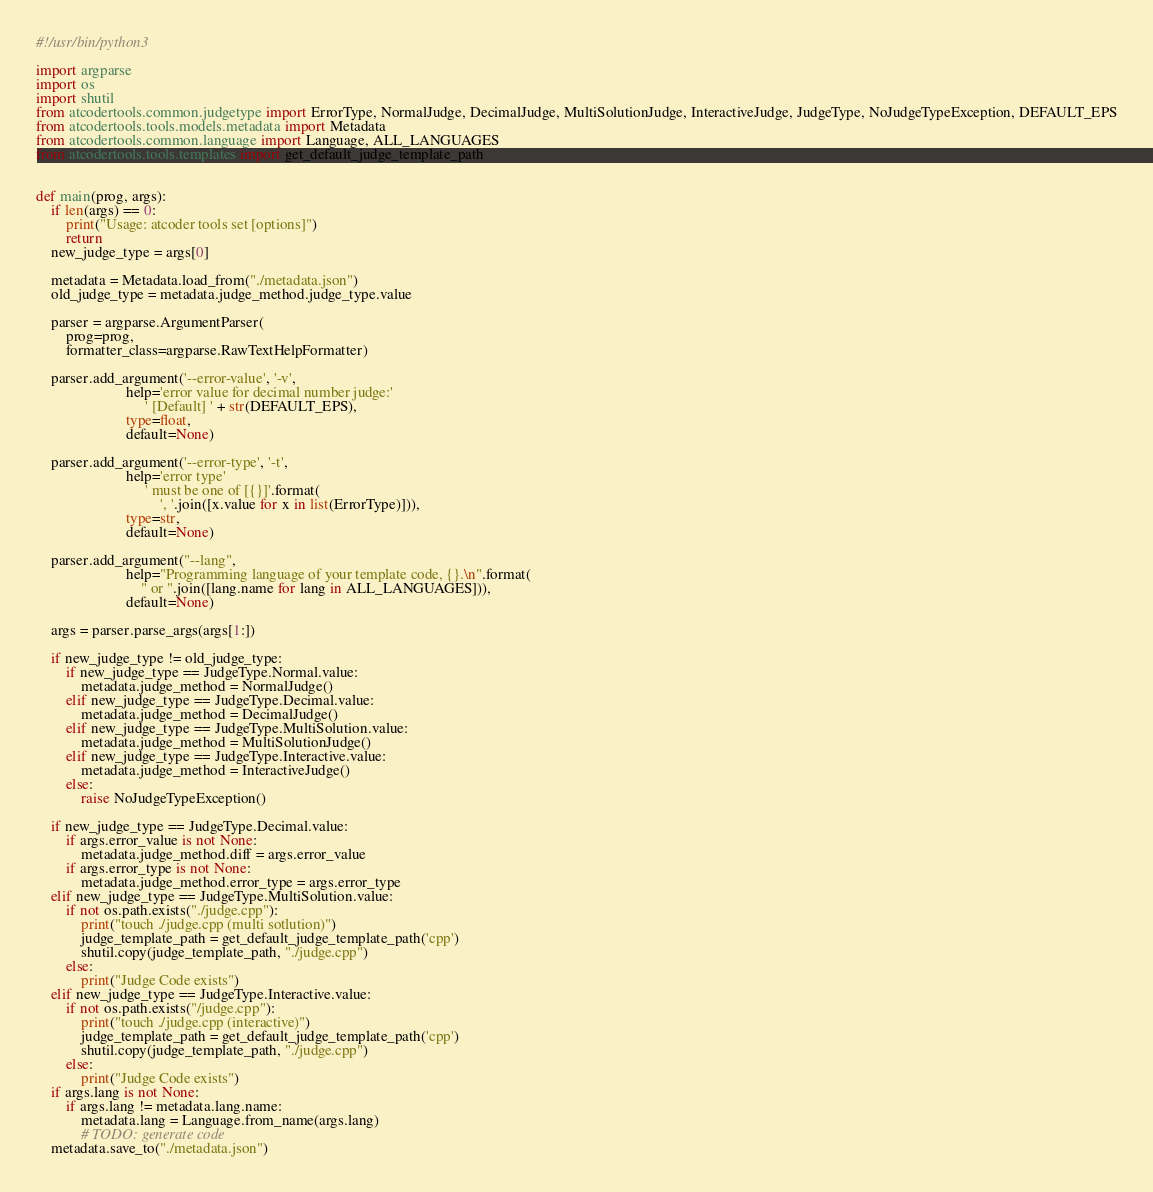Convert code to text. <code><loc_0><loc_0><loc_500><loc_500><_Python_>#!/usr/bin/python3

import argparse
import os
import shutil
from atcodertools.common.judgetype import ErrorType, NormalJudge, DecimalJudge, MultiSolutionJudge, InteractiveJudge, JudgeType, NoJudgeTypeException, DEFAULT_EPS
from atcodertools.tools.models.metadata import Metadata
from atcodertools.common.language import Language, ALL_LANGUAGES
from atcodertools.tools.templates import get_default_judge_template_path


def main(prog, args):
    if len(args) == 0:
        print("Usage: atcoder tools set [options]")
        return
    new_judge_type = args[0]

    metadata = Metadata.load_from("./metadata.json")
    old_judge_type = metadata.judge_method.judge_type.value

    parser = argparse.ArgumentParser(
        prog=prog,
        formatter_class=argparse.RawTextHelpFormatter)

    parser.add_argument('--error-value', '-v',
                        help='error value for decimal number judge:'
                             ' [Default] ' + str(DEFAULT_EPS),
                        type=float,
                        default=None)

    parser.add_argument('--error-type', '-t',
                        help='error type'
                             ' must be one of [{}]'.format(
                                 ', '.join([x.value for x in list(ErrorType)])),
                        type=str,
                        default=None)

    parser.add_argument("--lang",
                        help="Programming language of your template code, {}.\n".format(
                            " or ".join([lang.name for lang in ALL_LANGUAGES])),
                        default=None)

    args = parser.parse_args(args[1:])

    if new_judge_type != old_judge_type:
        if new_judge_type == JudgeType.Normal.value:
            metadata.judge_method = NormalJudge()
        elif new_judge_type == JudgeType.Decimal.value:
            metadata.judge_method = DecimalJudge()
        elif new_judge_type == JudgeType.MultiSolution.value:
            metadata.judge_method = MultiSolutionJudge()
        elif new_judge_type == JudgeType.Interactive.value:
            metadata.judge_method = InteractiveJudge()
        else:
            raise NoJudgeTypeException()

    if new_judge_type == JudgeType.Decimal.value:
        if args.error_value is not None:
            metadata.judge_method.diff = args.error_value
        if args.error_type is not None:
            metadata.judge_method.error_type = args.error_type
    elif new_judge_type == JudgeType.MultiSolution.value:
        if not os.path.exists("./judge.cpp"):
            print("touch ./judge.cpp (multi sotlution)")
            judge_template_path = get_default_judge_template_path('cpp')
            shutil.copy(judge_template_path, "./judge.cpp")
        else:
            print("Judge Code exists")
    elif new_judge_type == JudgeType.Interactive.value:
        if not os.path.exists("/judge.cpp"):
            print("touch ./judge.cpp (interactive)")
            judge_template_path = get_default_judge_template_path('cpp')
            shutil.copy(judge_template_path, "./judge.cpp")
        else:
            print("Judge Code exists")
    if args.lang is not None:
        if args.lang != metadata.lang.name:
            metadata.lang = Language.from_name(args.lang)
            # TODO: generate code
    metadata.save_to("./metadata.json")
</code> 